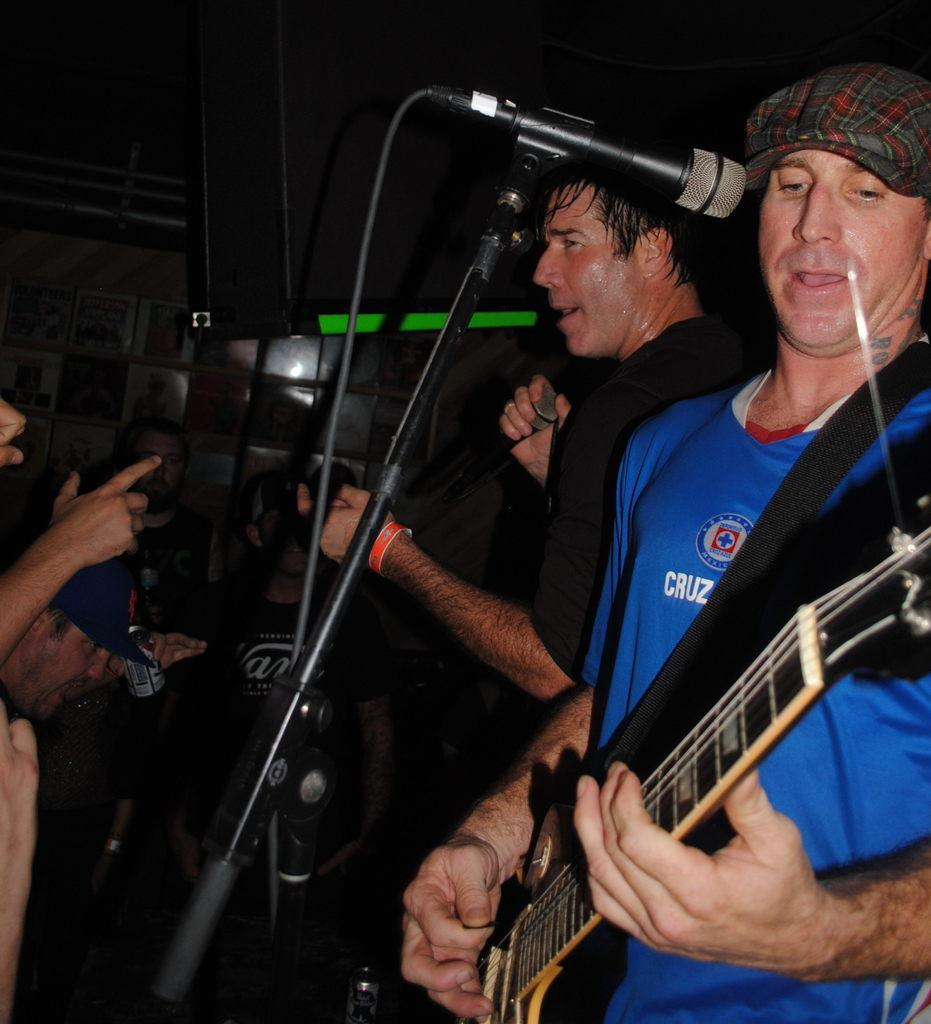How many people are in the image? There is a group of people in the image. What is one person in the group doing? One person is standing in front of a mic. What instrument is the person playing? The person is playing the guitar. What type of trees can be seen in the background of the image? There are no trees visible in the image; it features a group of people with one person playing the guitar and standing in front of a mic. 